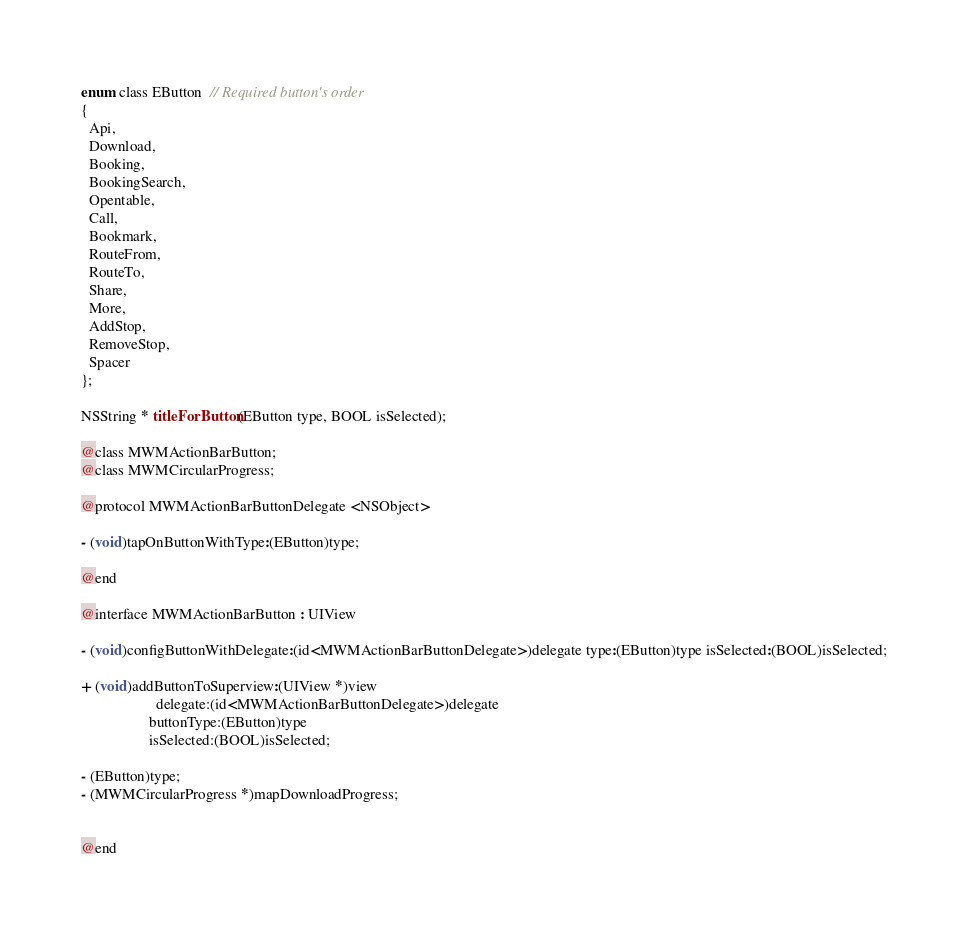<code> <loc_0><loc_0><loc_500><loc_500><_C_>enum class EButton  // Required button's order
{
  Api,
  Download,
  Booking,
  BookingSearch,
  Opentable,
  Call,
  Bookmark,
  RouteFrom,
  RouteTo,
  Share,
  More,
  AddStop,
  RemoveStop,
  Spacer
};

NSString * titleForButton(EButton type, BOOL isSelected);

@class MWMActionBarButton;
@class MWMCircularProgress;

@protocol MWMActionBarButtonDelegate <NSObject>

- (void)tapOnButtonWithType:(EButton)type;

@end

@interface MWMActionBarButton : UIView

- (void)configButtonWithDelegate:(id<MWMActionBarButtonDelegate>)delegate type:(EButton)type isSelected:(BOOL)isSelected;

+ (void)addButtonToSuperview:(UIView *)view
                    delegate:(id<MWMActionBarButtonDelegate>)delegate
                  buttonType:(EButton)type
                  isSelected:(BOOL)isSelected;

- (EButton)type;
- (MWMCircularProgress *)mapDownloadProgress;


@end
</code> 